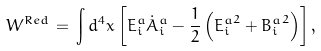<formula> <loc_0><loc_0><loc_500><loc_500>W ^ { R e d } \, = \, \int d ^ { 4 } x \left [ E _ { i } ^ { a } { \dot { A } } _ { i } ^ { a } - \frac { 1 } { 2 } \left ( { E _ { i } ^ { a } } ^ { 2 } + { B _ { i } ^ { a } } ^ { 2 } \right ) \right ] ,</formula> 